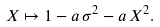Convert formula to latex. <formula><loc_0><loc_0><loc_500><loc_500>X \mapsto 1 - a \, \sigma ^ { 2 } - a \, X ^ { 2 } .</formula> 